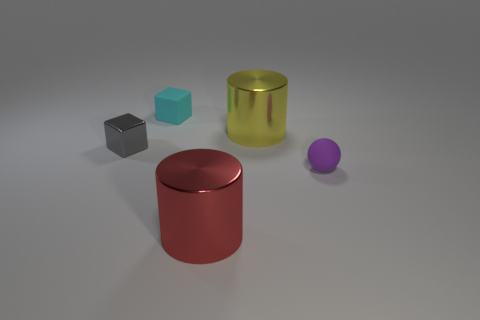Is there a small matte object that is right of the cylinder behind the large red metal object?
Make the answer very short. Yes. Are there any big red cylinders that have the same material as the gray cube?
Provide a short and direct response. Yes. How many big metal objects are there?
Keep it short and to the point. 2. There is a tiny object that is on the right side of the matte object behind the purple rubber object; what is its material?
Provide a short and direct response. Rubber. There is a tiny sphere that is the same material as the cyan thing; what is its color?
Your response must be concise. Purple. There is a metallic thing that is to the left of the cyan cube; is its size the same as the shiny object that is in front of the tiny metallic thing?
Keep it short and to the point. No. How many cylinders are small shiny things or metal things?
Your answer should be compact. 2. Is the large cylinder behind the red shiny thing made of the same material as the big red cylinder?
Offer a terse response. Yes. How many other objects are there of the same size as the rubber block?
Give a very brief answer. 2. How many small things are cyan rubber cylinders or cyan blocks?
Provide a short and direct response. 1. 